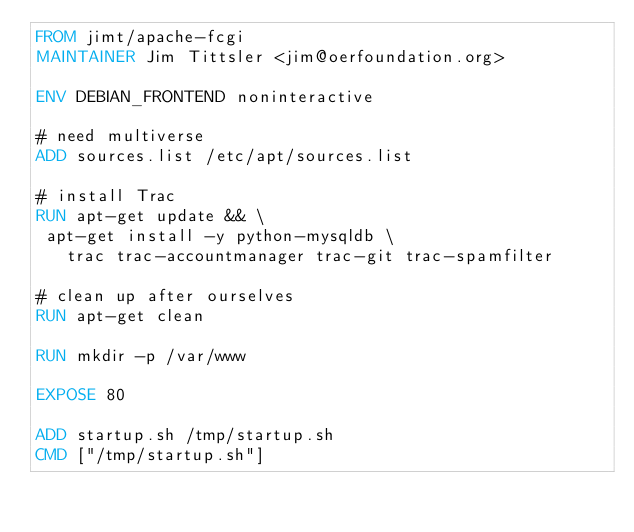<code> <loc_0><loc_0><loc_500><loc_500><_Dockerfile_>FROM jimt/apache-fcgi
MAINTAINER Jim Tittsler <jim@oerfoundation.org>

ENV DEBIAN_FRONTEND noninteractive

# need multiverse
ADD sources.list /etc/apt/sources.list

# install Trac
RUN apt-get update && \
 apt-get install -y python-mysqldb \
   trac trac-accountmanager trac-git trac-spamfilter

# clean up after ourselves
RUN apt-get clean

RUN mkdir -p /var/www

EXPOSE 80

ADD startup.sh /tmp/startup.sh
CMD ["/tmp/startup.sh"]

</code> 